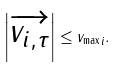Convert formula to latex. <formula><loc_0><loc_0><loc_500><loc_500>\left | \overrightarrow { v _ { i , \tau } } \right | \leq { v _ { \max } } _ { i } .</formula> 